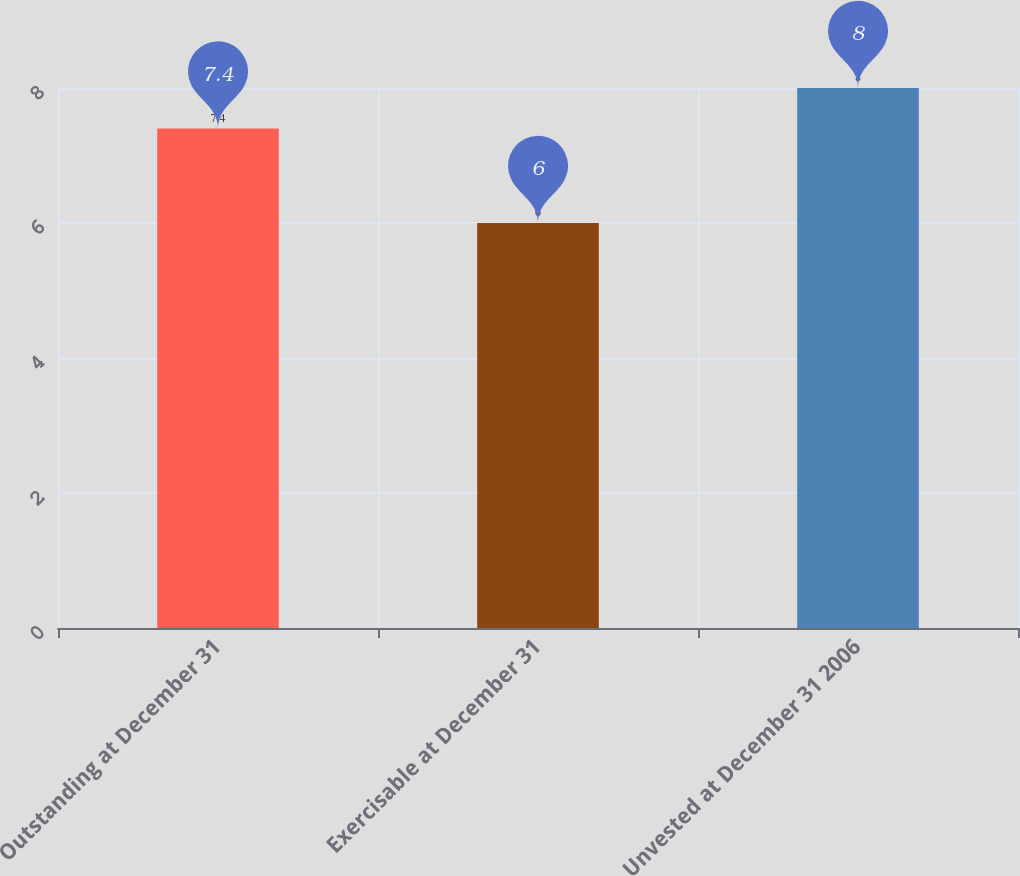Convert chart. <chart><loc_0><loc_0><loc_500><loc_500><bar_chart><fcel>Outstanding at December 31<fcel>Exercisable at December 31<fcel>Unvested at December 31 2006<nl><fcel>7.4<fcel>6<fcel>8<nl></chart> 